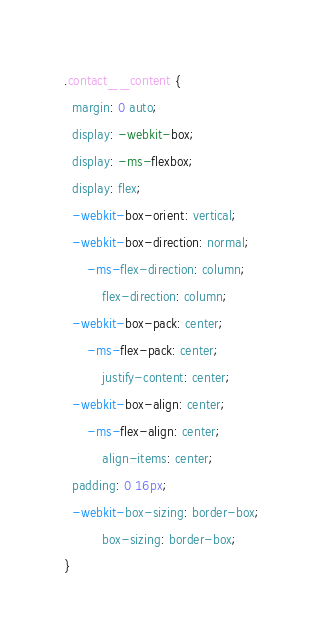Convert code to text. <code><loc_0><loc_0><loc_500><loc_500><_CSS_>.contact__content {
  margin: 0 auto;
  display: -webkit-box;
  display: -ms-flexbox;
  display: flex;
  -webkit-box-orient: vertical;
  -webkit-box-direction: normal;
      -ms-flex-direction: column;
          flex-direction: column;
  -webkit-box-pack: center;
      -ms-flex-pack: center;
          justify-content: center;
  -webkit-box-align: center;
      -ms-flex-align: center;
          align-items: center;
  padding: 0 16px;
  -webkit-box-sizing: border-box;
          box-sizing: border-box;
}
</code> 